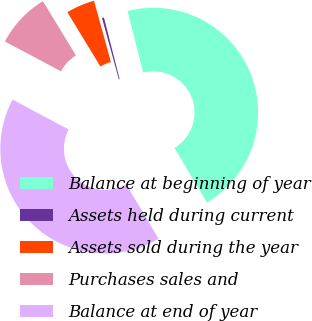Convert chart to OTSL. <chart><loc_0><loc_0><loc_500><loc_500><pie_chart><fcel>Balance at beginning of year<fcel>Assets held during current<fcel>Assets sold during the year<fcel>Purchases sales and<fcel>Balance at end of year<nl><fcel>45.43%<fcel>0.31%<fcel>4.42%<fcel>8.53%<fcel>41.32%<nl></chart> 